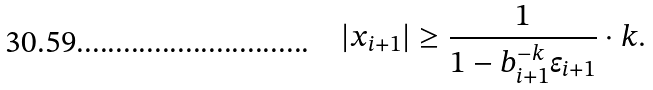<formula> <loc_0><loc_0><loc_500><loc_500>| x _ { i + 1 } | \geq \frac { 1 } { 1 - b _ { i + 1 } ^ { - k } \epsilon _ { i + 1 } } \cdot k .</formula> 